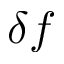<formula> <loc_0><loc_0><loc_500><loc_500>\delta f</formula> 